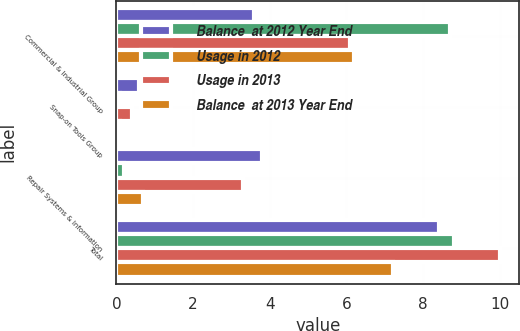<chart> <loc_0><loc_0><loc_500><loc_500><stacked_bar_chart><ecel><fcel>Commercial & Industrial Group<fcel>Snap-on Tools Group<fcel>Repair Systems & Information<fcel>Total<nl><fcel>Balance  at 2012 Year End<fcel>3.6<fcel>0.6<fcel>3.8<fcel>8.4<nl><fcel>Usage in 2012<fcel>8.7<fcel>0.1<fcel>0.2<fcel>8.8<nl><fcel>Usage in 2013<fcel>6.1<fcel>0.4<fcel>3.3<fcel>10<nl><fcel>Balance  at 2013 Year End<fcel>6.2<fcel>0.1<fcel>0.7<fcel>7.2<nl></chart> 